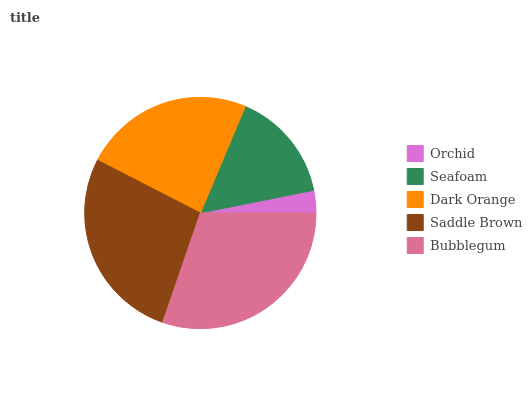Is Orchid the minimum?
Answer yes or no. Yes. Is Bubblegum the maximum?
Answer yes or no. Yes. Is Seafoam the minimum?
Answer yes or no. No. Is Seafoam the maximum?
Answer yes or no. No. Is Seafoam greater than Orchid?
Answer yes or no. Yes. Is Orchid less than Seafoam?
Answer yes or no. Yes. Is Orchid greater than Seafoam?
Answer yes or no. No. Is Seafoam less than Orchid?
Answer yes or no. No. Is Dark Orange the high median?
Answer yes or no. Yes. Is Dark Orange the low median?
Answer yes or no. Yes. Is Saddle Brown the high median?
Answer yes or no. No. Is Seafoam the low median?
Answer yes or no. No. 